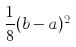Convert formula to latex. <formula><loc_0><loc_0><loc_500><loc_500>\frac { 1 } { 8 } ( b - a ) ^ { 2 }</formula> 